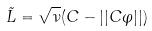<formula> <loc_0><loc_0><loc_500><loc_500>\tilde { L } = \sqrt { \nu } ( C - | | C \varphi | | )</formula> 